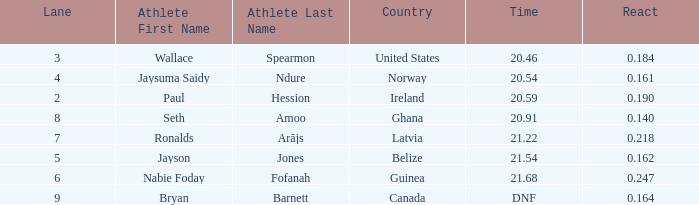What is the lowest lane when react is more than 0.164 and the nationality is guinea? 6.0. 